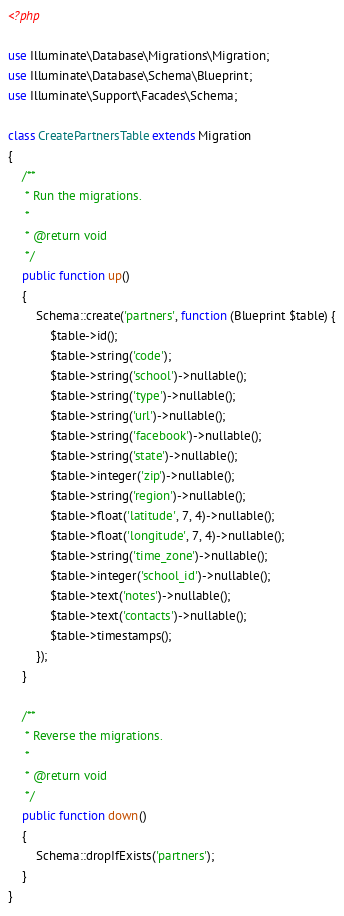Convert code to text. <code><loc_0><loc_0><loc_500><loc_500><_PHP_><?php

use Illuminate\Database\Migrations\Migration;
use Illuminate\Database\Schema\Blueprint;
use Illuminate\Support\Facades\Schema;

class CreatePartnersTable extends Migration
{
    /**
     * Run the migrations.
     *
     * @return void
     */
    public function up()
    {
        Schema::create('partners', function (Blueprint $table) {
            $table->id();
            $table->string('code');
            $table->string('school')->nullable();
            $table->string('type')->nullable();
            $table->string('url')->nullable();
            $table->string('facebook')->nullable();
            $table->string('state')->nullable();
            $table->integer('zip')->nullable();
            $table->string('region')->nullable();
            $table->float('latitude', 7, 4)->nullable();
            $table->float('longitude', 7, 4)->nullable();
            $table->string('time_zone')->nullable();
            $table->integer('school_id')->nullable();
            $table->text('notes')->nullable();
            $table->text('contacts')->nullable();
            $table->timestamps();
        });
    }

    /**
     * Reverse the migrations.
     *
     * @return void
     */
    public function down()
    {
        Schema::dropIfExists('partners');
    }
}
</code> 